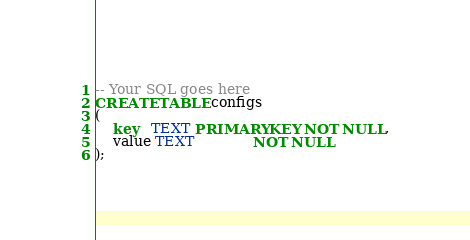Convert code to text. <code><loc_0><loc_0><loc_500><loc_500><_SQL_>-- Your SQL goes here
CREATE TABLE configs
(
    key   TEXT PRIMARY KEY NOT NULL,
    value TEXT             NOT NULL
);</code> 